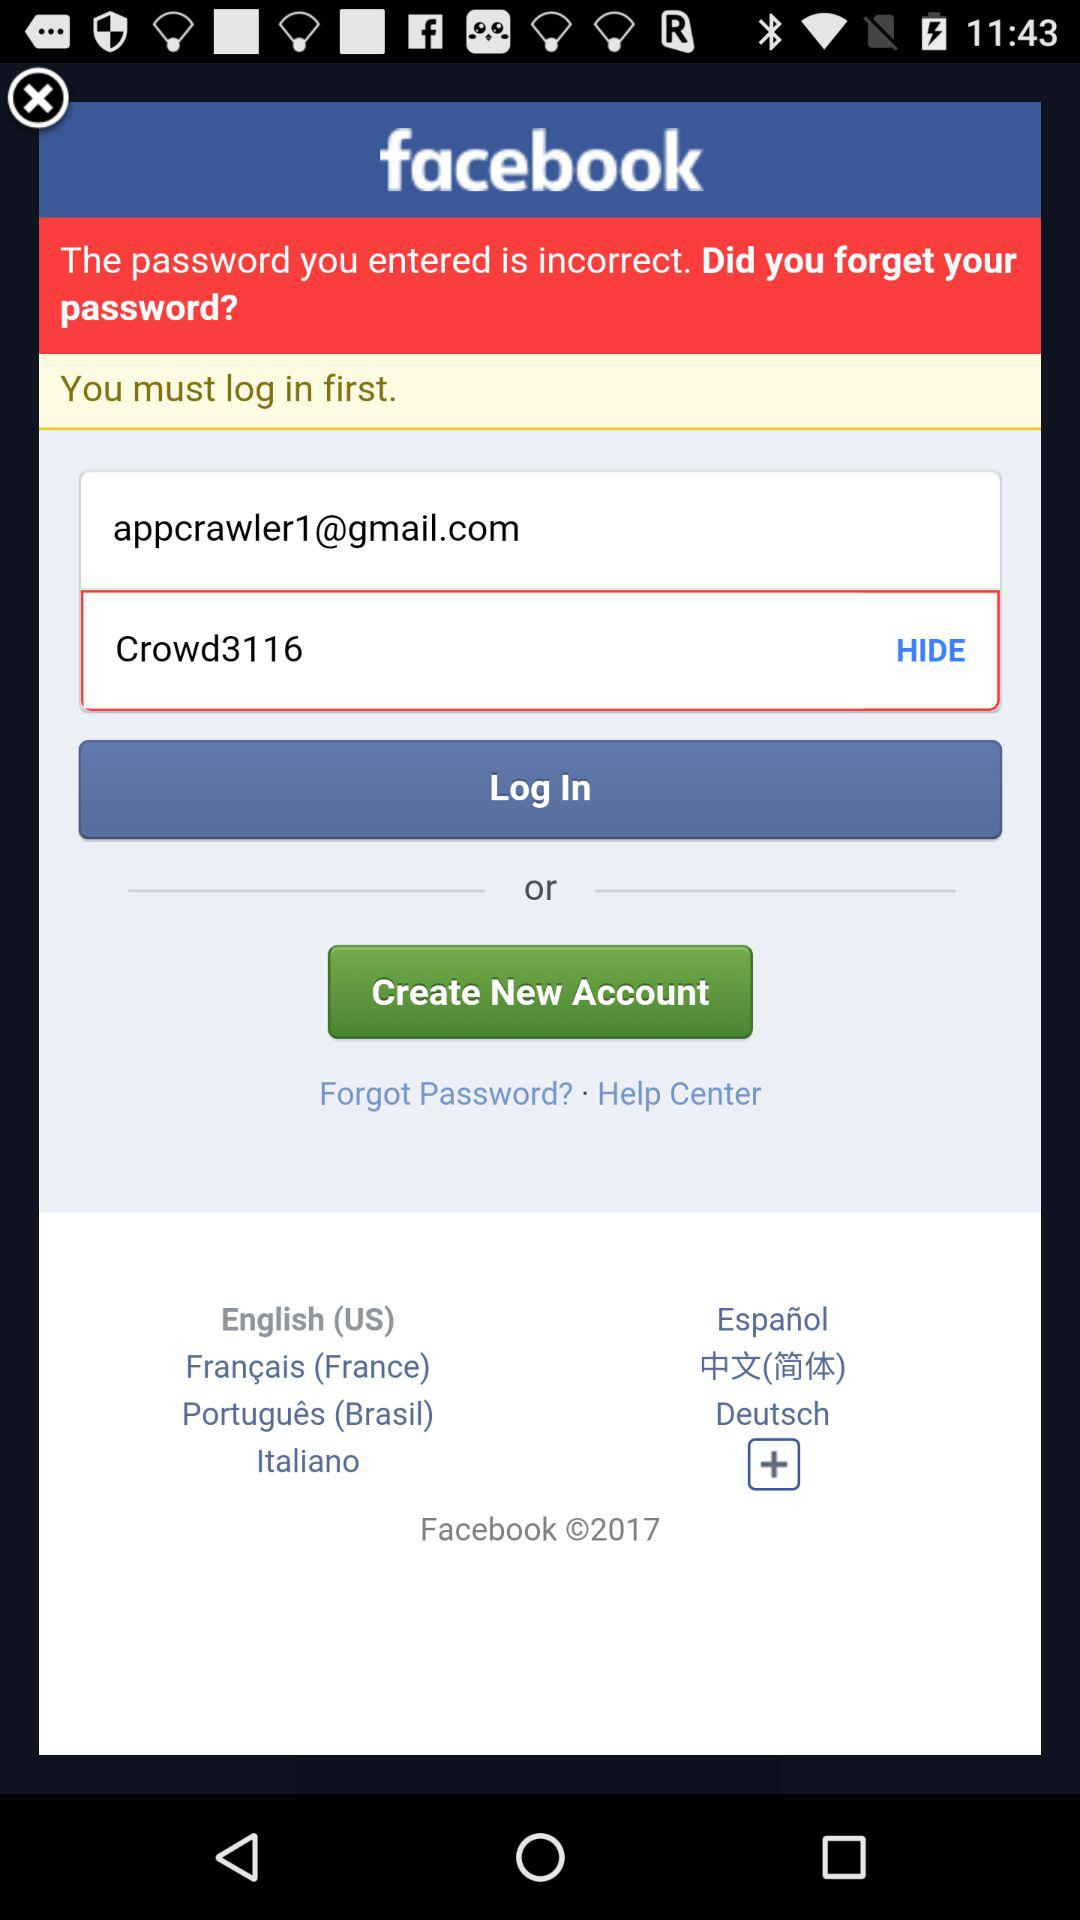How many text inputs are present on the page?
Answer the question using a single word or phrase. 2 